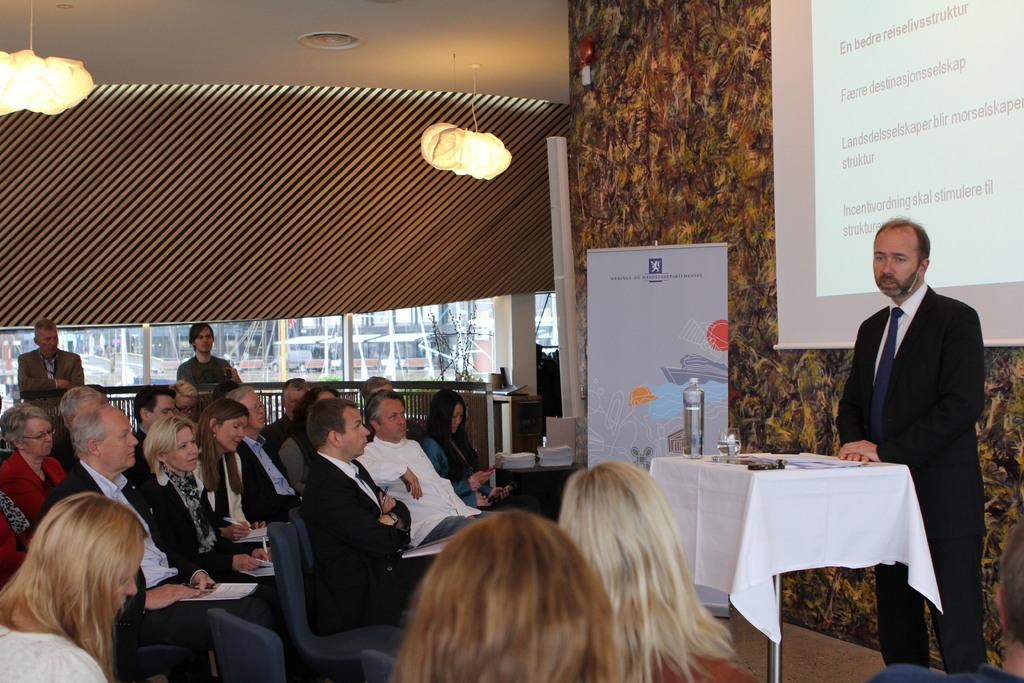What is located at the top of the image? There is a light at the top of the image. Where are the people in the image seated? There is a group of people sitting on chairs on the left side of the image. What is the man on the right side of the image doing? There is a man standing on the right side of the image. What type of flowers are on the notebook in the image? There is no notebook or flowers present in the image. How many seats are available for the people in the image? The question cannot be answered definitively, as the number of chairs is not specified in the provided facts. 